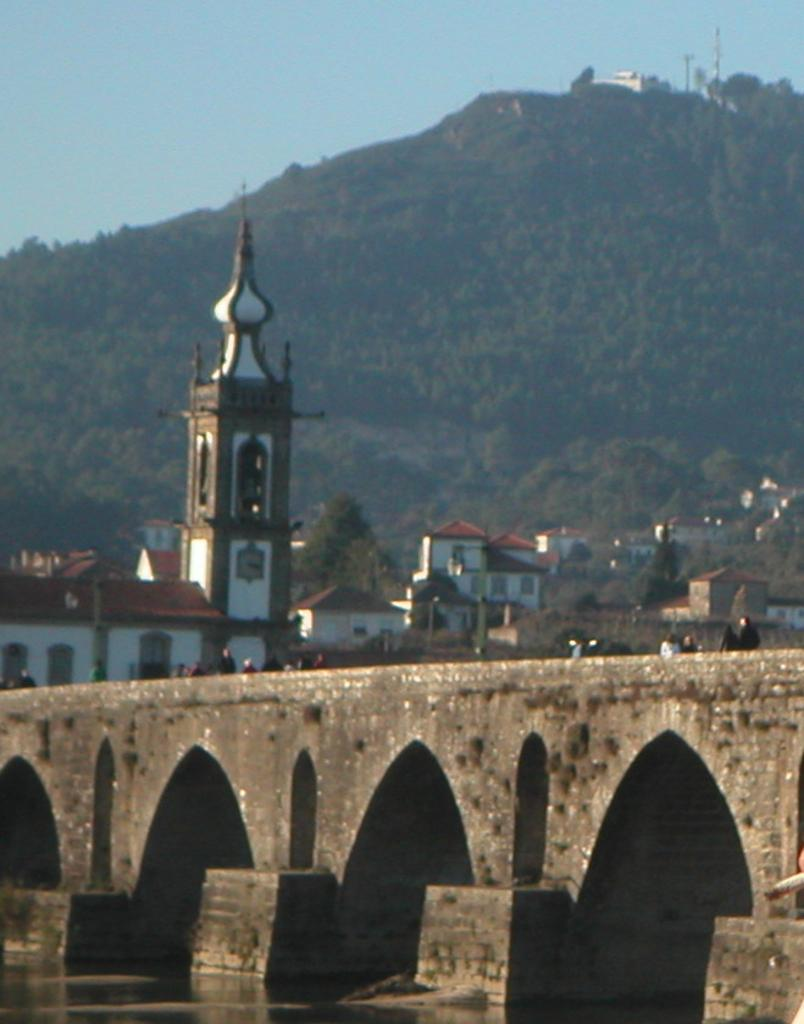What structure is located at the bottom of the image? There is a bridge at the bottom of the image. What can be seen in the middle of the image? Buildings and trees are visible in the middle of the image. What is located behind the buildings in the image? There is a mountain behind the buildings. What is visible in the background of the image? The sky is in the background of the image. What book is being read by the mountain in the image? There is no book or reading activity depicted in the image; the mountain is a natural formation and does not engage in such activities. 